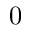Convert formula to latex. <formula><loc_0><loc_0><loc_500><loc_500>0</formula> 